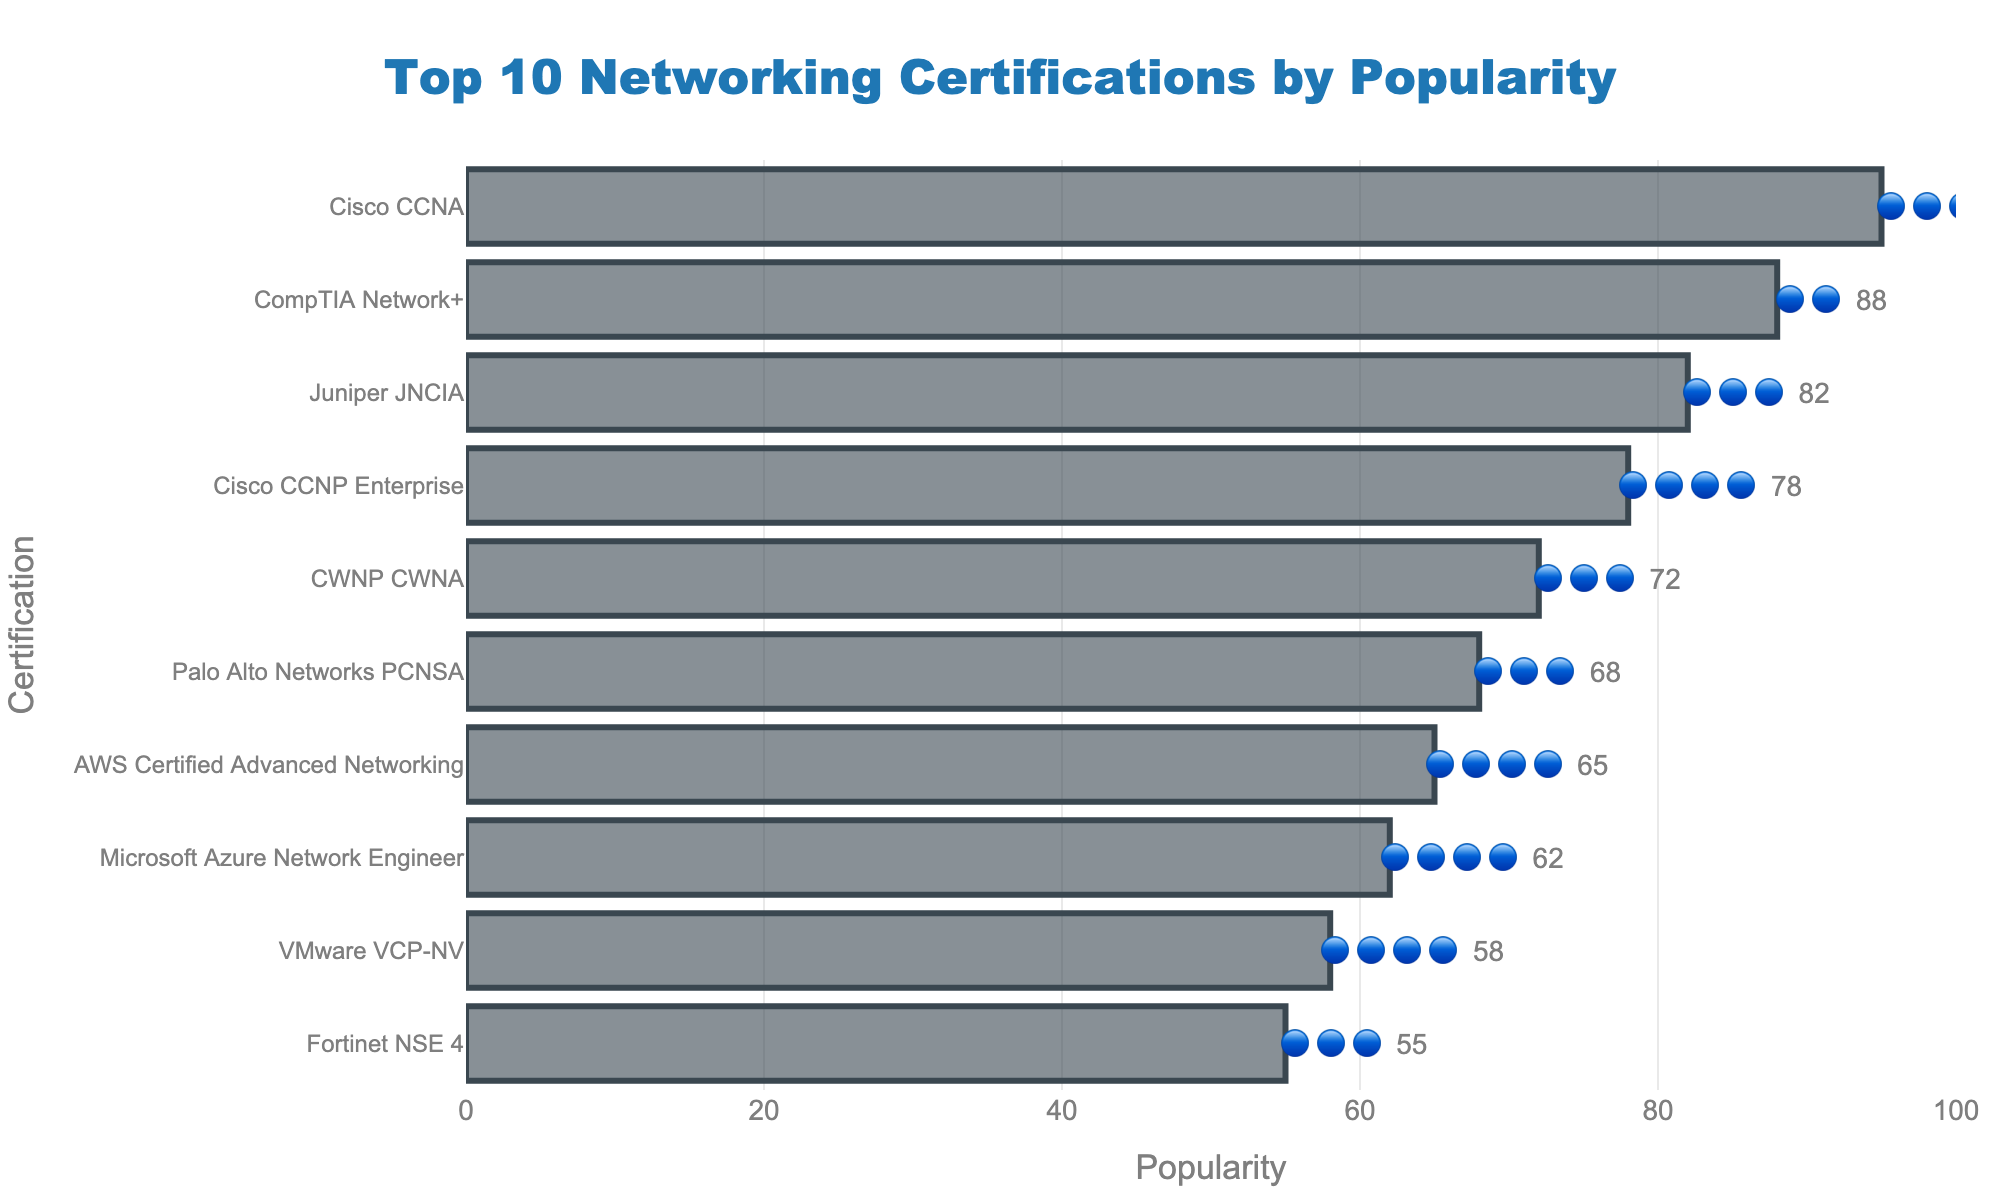What is the title of the figure? The title is usually displayed at the top of the figure. In this case, it is centered and reads "Top 10 Networking Certifications by Popularity".
Answer: Top 10 Networking Certifications by Popularity Which certification is the most popular? The most popular certification is the one with the highest value on the x-axis. Here, "Cisco CCNA" has the highest popularity value of 95.
Answer: Cisco CCNA How many certifications have a skill level of four blue circles? By examining the text labels next to the bars, we see that four certifications display four blue circles (🔵🔵🔵🔵) next to their popularity. These are "Cisco CCNP Enterprise", "AWS Certified Advanced Networking", "Microsoft Azure Network Engineer", and "VMware VCP-NV".
Answer: 4 What is the least popular certification and what is its skill level? The least popular certification is the one with the lowest value on the x-axis. "Fortinet NSE 4" is the least popular with a popularity of 55, and it has a skill level of three blue circles (🔵🔵🔵).
Answer: Fortinet NSE 4, 🔵🔵🔵 Which certification has a higher popularity: CWNP CWNA or AWS Certified Advanced Networking? By comparing the values on the x-axis, CWNP CWNA has a popularity of 72, whereas AWS Certified Advanced Networking has a popularity of 65. Thus, CWNP CWNA is more popular.
Answer: CWNP CWNA What's the difference in popularity between Palo Alto Networks PCNSA and Juniper JNCIA? Palo Alto Networks PCNSA has a popularity of 68, and Juniper JNCIA has a popularity of 82. Their popularity difference is calculated as 82 - 68.
Answer: 14 What certifications have a skill level of exactly three blue circles (🔵🔵🔵)? By examining the text labels next to the bars, the certifications with three blue circles are "Cisco CCNA", "Juniper JNCIA", "CWNP CWNA", "Palo Alto Networks PCNSA", and "Fortinet NSE 4".
Answer: Cisco CCNA, Juniper JNCIA, CWNP CWNA, Palo Alto Networks PCNSA, Fortinet NSE 4 Which certification is more popular, Microsoft Azure Network Engineer or VMware VCP-NV? And by how much? Microsoft Azure Network Engineer has a popularity of 62, while VMware VCP-NV has a popularity of 58. The difference in popularity is calculated as 62 - 58.
Answer: Microsoft Azure Network Engineer, 4 What is the average popularity of the top 3 most popular certifications? The top 3 most popular certifications are "Cisco CCNA" (95), "CompTIA Network+" (88), and "Juniper JNCIA" (82). The average is calculated as (95 + 88 + 82) / 3.
Answer: 88.33 